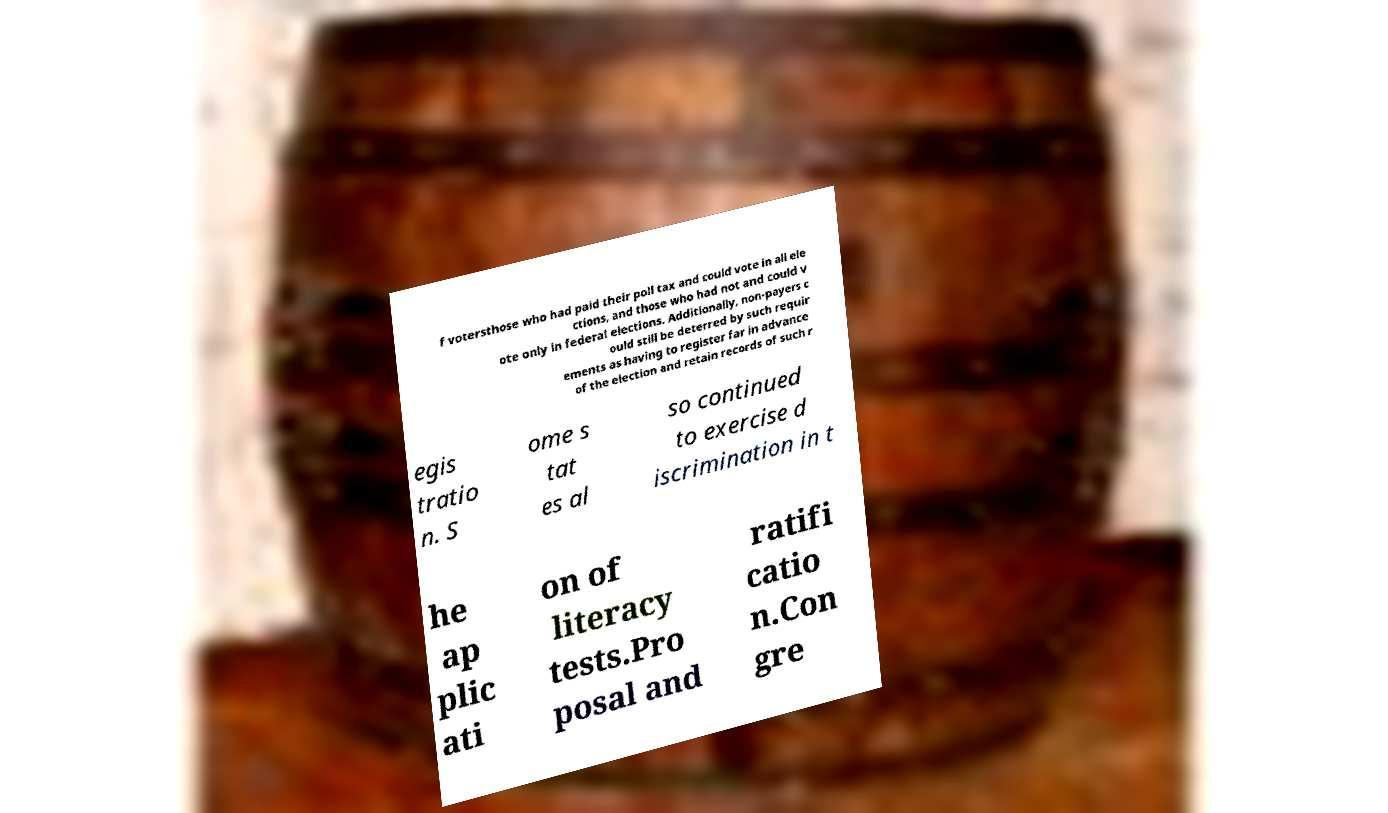What messages or text are displayed in this image? I need them in a readable, typed format. f votersthose who had paid their poll tax and could vote in all ele ctions, and those who had not and could v ote only in federal elections. Additionally, non-payers c ould still be deterred by such requir ements as having to register far in advance of the election and retain records of such r egis tratio n. S ome s tat es al so continued to exercise d iscrimination in t he ap plic ati on of literacy tests.Pro posal and ratifi catio n.Con gre 